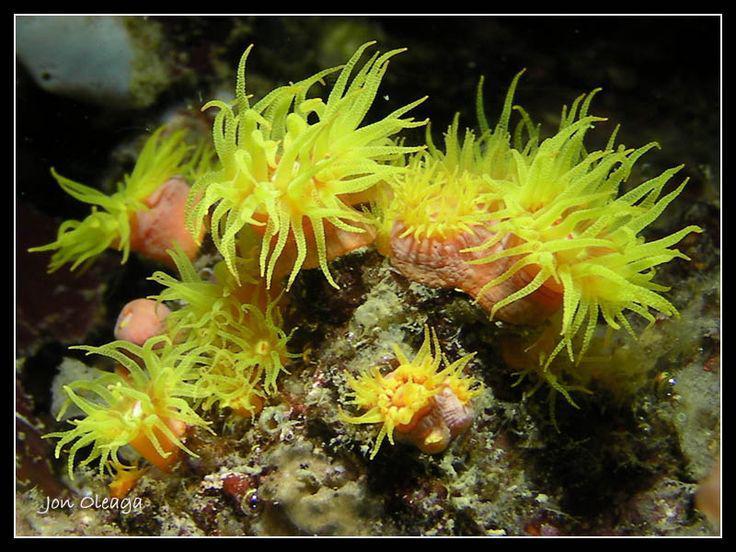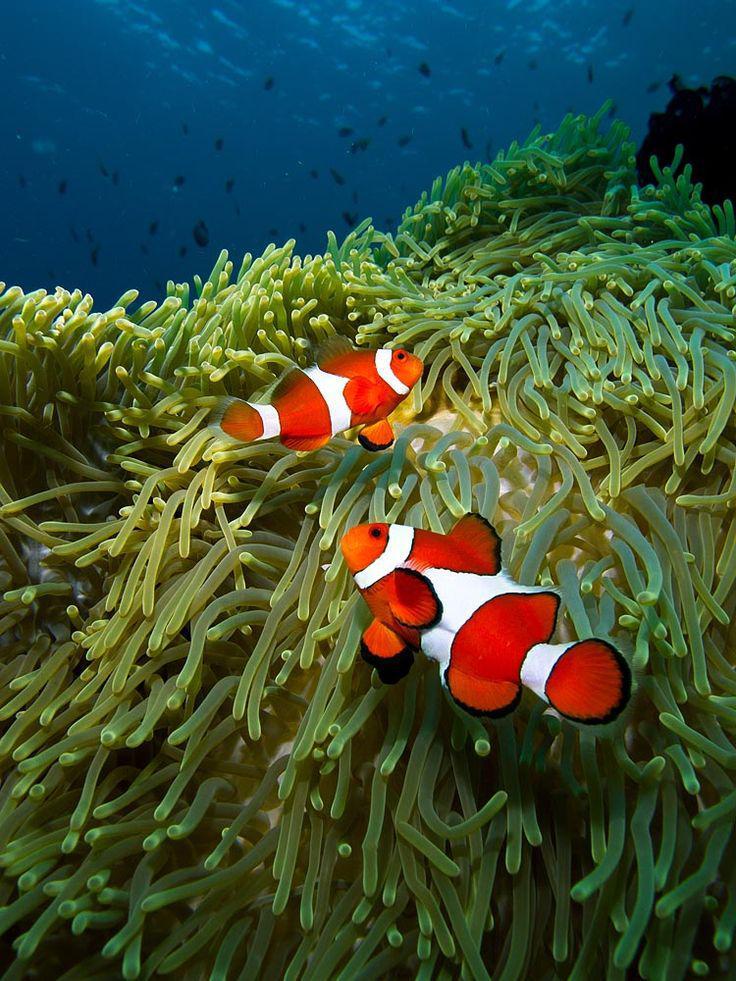The first image is the image on the left, the second image is the image on the right. Assess this claim about the two images: "The right image contains at least two clown fish.". Correct or not? Answer yes or no. Yes. The first image is the image on the left, the second image is the image on the right. Examine the images to the left and right. Is the description "The right image features at least one clown fish swimming in front of anemone tendrils, and the left image includes at least one anemone with tapering tendrils and an orange stalk." accurate? Answer yes or no. Yes. 